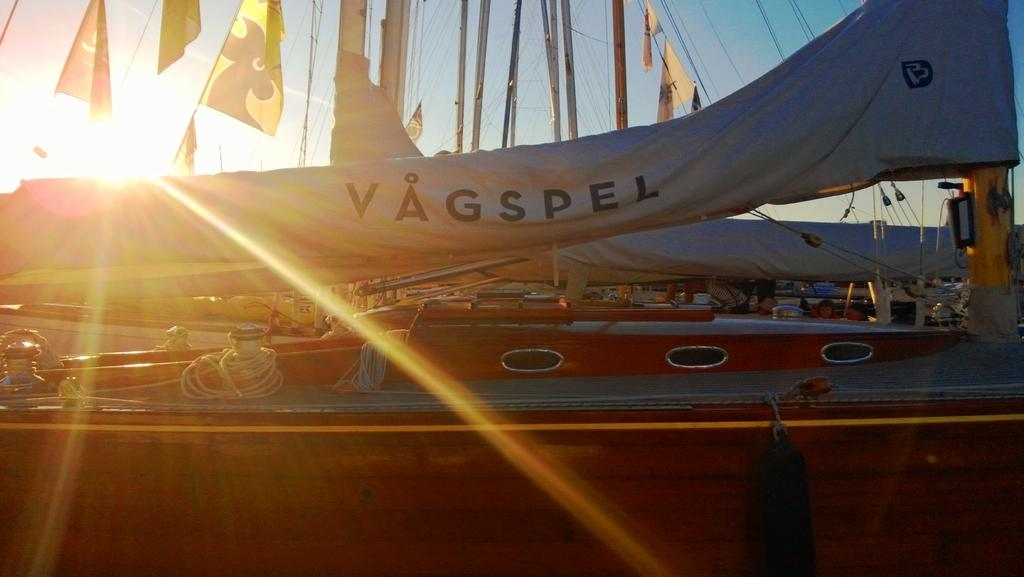<image>
Present a compact description of the photo's key features. A large tarp is being lifted off of something with the word VAGSPEL. 